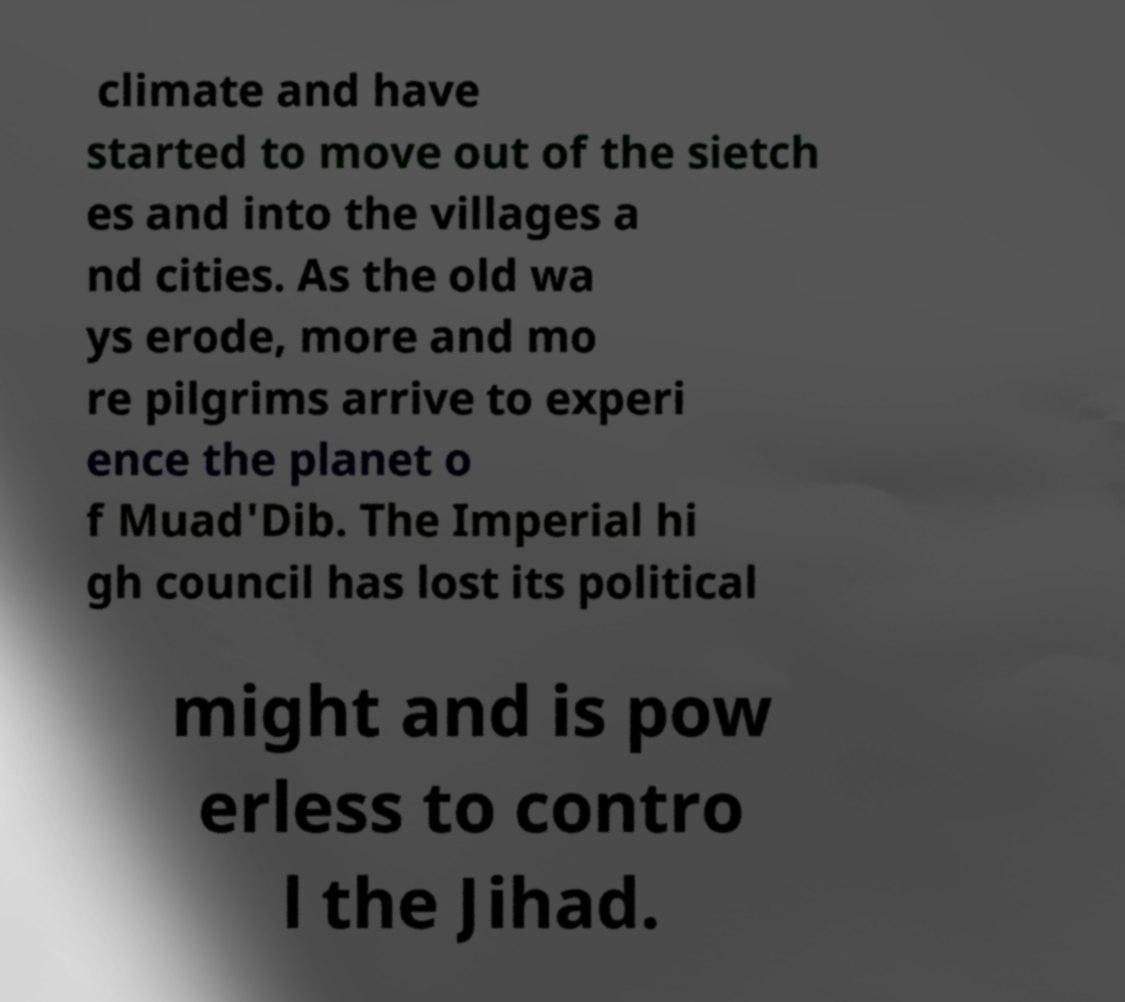Please read and relay the text visible in this image. What does it say? climate and have started to move out of the sietch es and into the villages a nd cities. As the old wa ys erode, more and mo re pilgrims arrive to experi ence the planet o f Muad'Dib. The Imperial hi gh council has lost its political might and is pow erless to contro l the Jihad. 